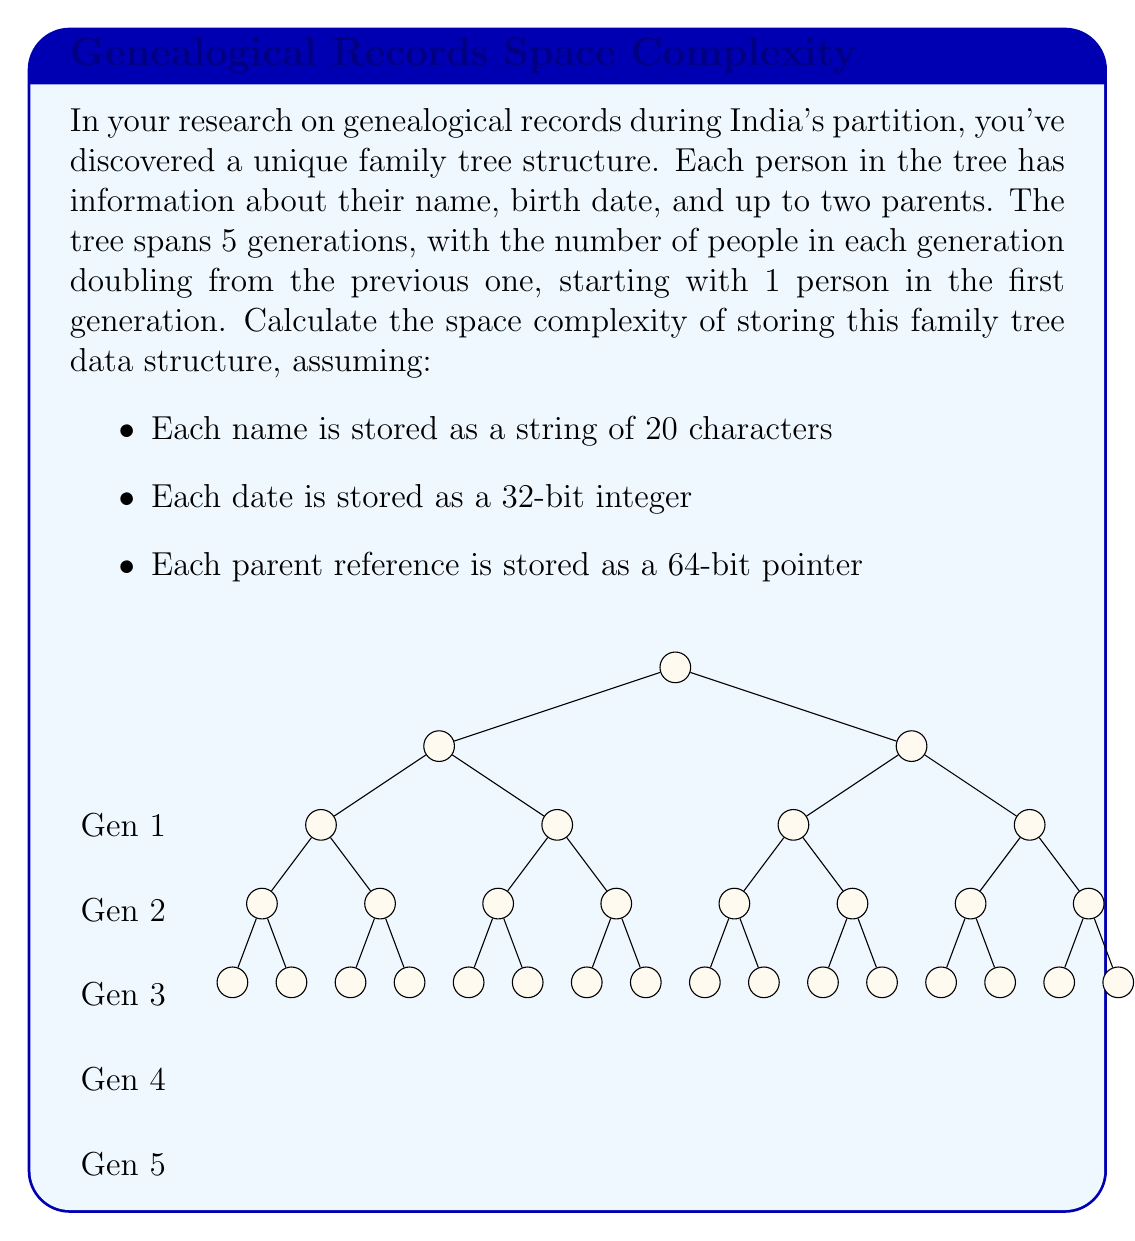Teach me how to tackle this problem. Let's approach this step-by-step:

1) First, calculate the total number of people in the tree:
   $$ \text{Total people} = 1 + 2 + 4 + 8 + 16 = 2^0 + 2^1 + 2^2 + 2^3 + 2^4 = 2^5 - 1 = 31 $$

2) For each person, we need to store:
   - Name: 20 characters * 1 byte per character = 20 bytes
   - Birth date: 32 bits = 4 bytes
   - Two parent pointers: 2 * 64 bits = 16 bytes

3) Total space per person:
   $$ \text{Space per person} = 20 + 4 + 16 = 40 \text{ bytes} $$

4) Total space for all people:
   $$ \text{Total space} = 31 * 40 = 1240 \text{ bytes} $$

5) In Big O notation, we express this as $O(n)$, where $n$ is the number of people in the tree. This is because the space required grows linearly with the number of people.

6) However, we can also express it in terms of the number of generations $g$. The number of people in a tree with $g$ generations is $2^g - 1$. So the space complexity can be written as $O(2^g)$.
Answer: $O(2^g)$ or $O(n)$, where $g$ is the number of generations and $n$ is the number of people 